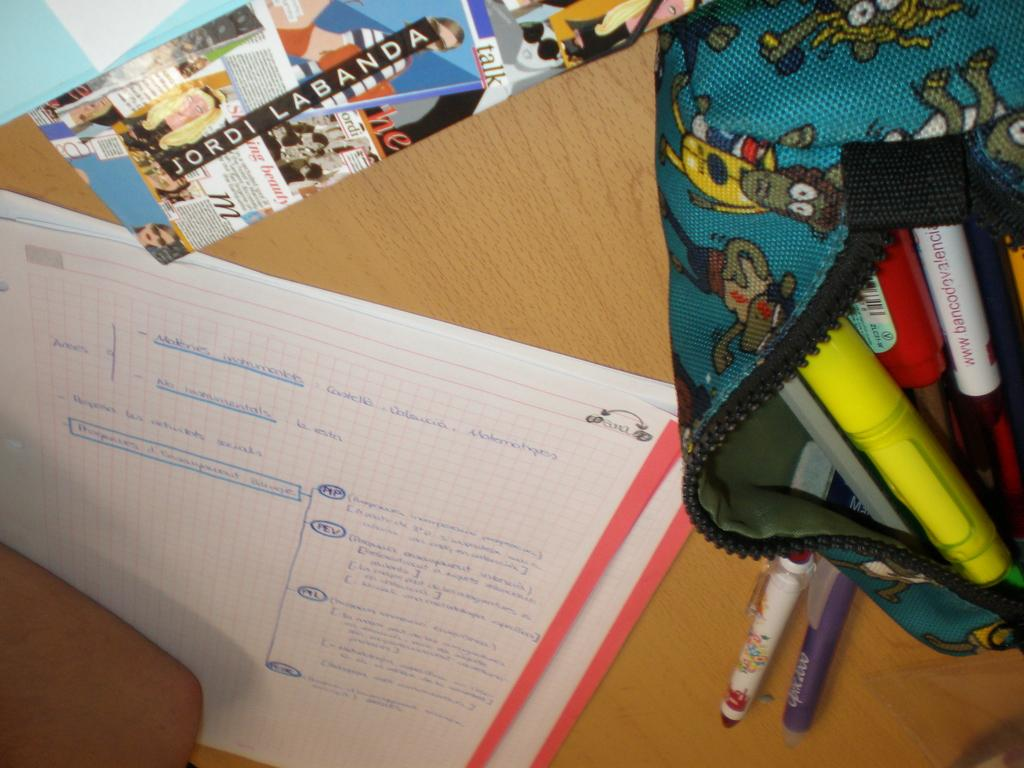<image>
Provide a brief description of the given image. A desk with a sticker that says Jordi Labanda has an open purse with markers in it. 